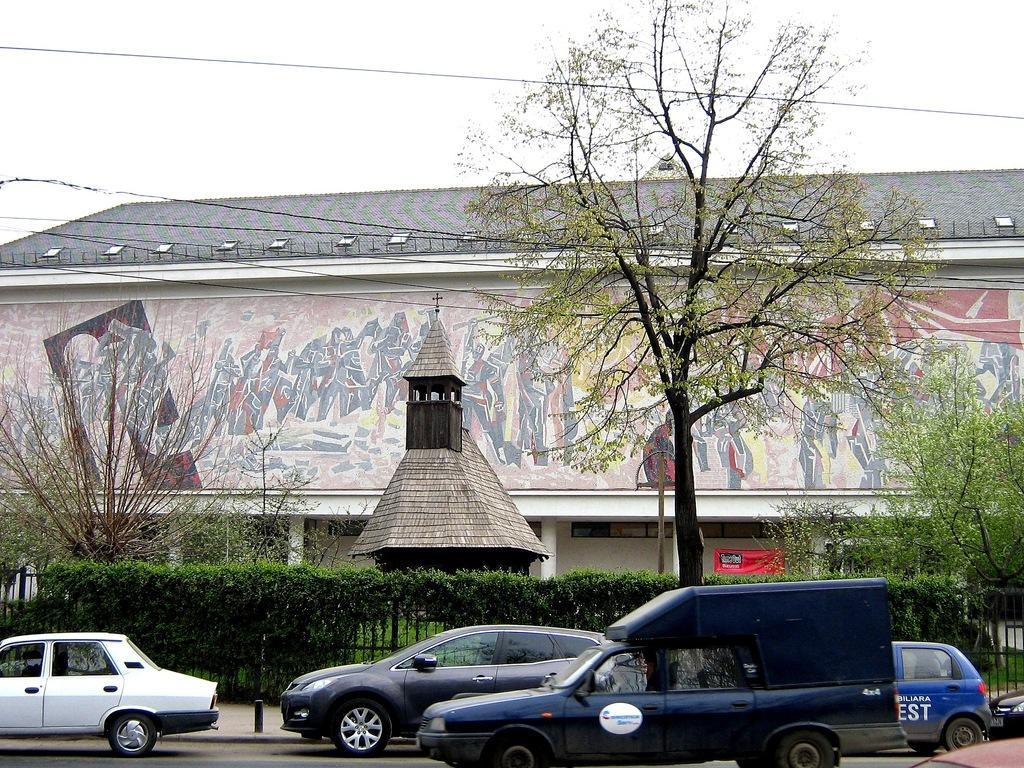Describe this image in one or two sentences. In the foreground of this image, there are vehicles moving on the road. In the background to the fencing, there are plants, trees, a hut like an object, a building, a cable and the sky. 